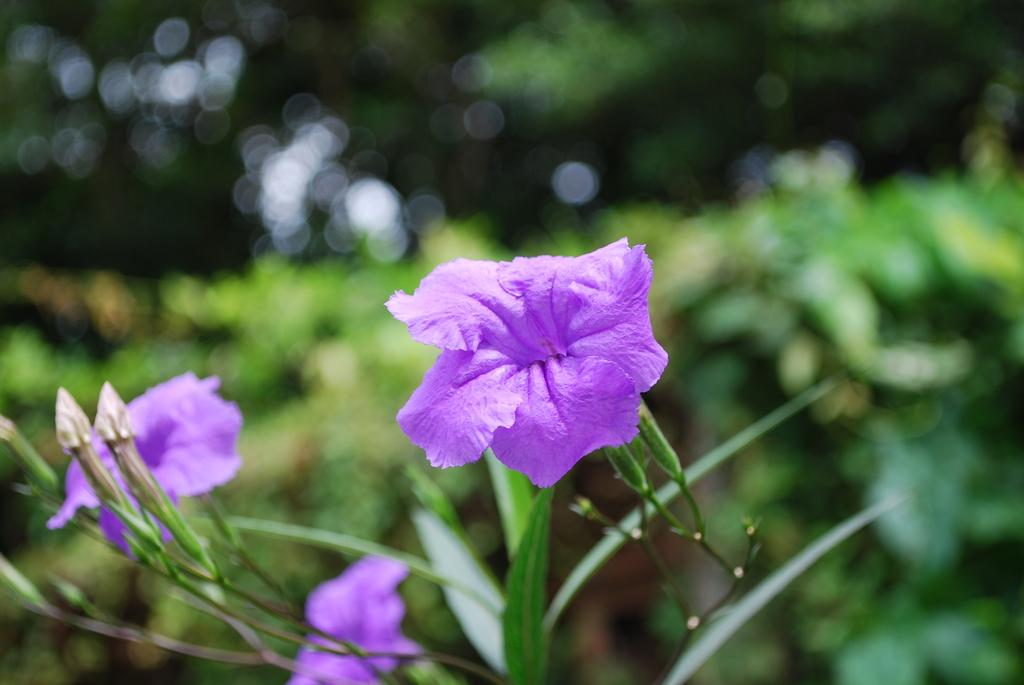What color are the flowers in the image? The flowers in the image are purple. What can be seen in the background of the image? There are green color plants and trees in the background of the image. What type of leather material is used to make the jeans in the image? There are no jeans present in the image, so it is not possible to determine the type of leather material used. 